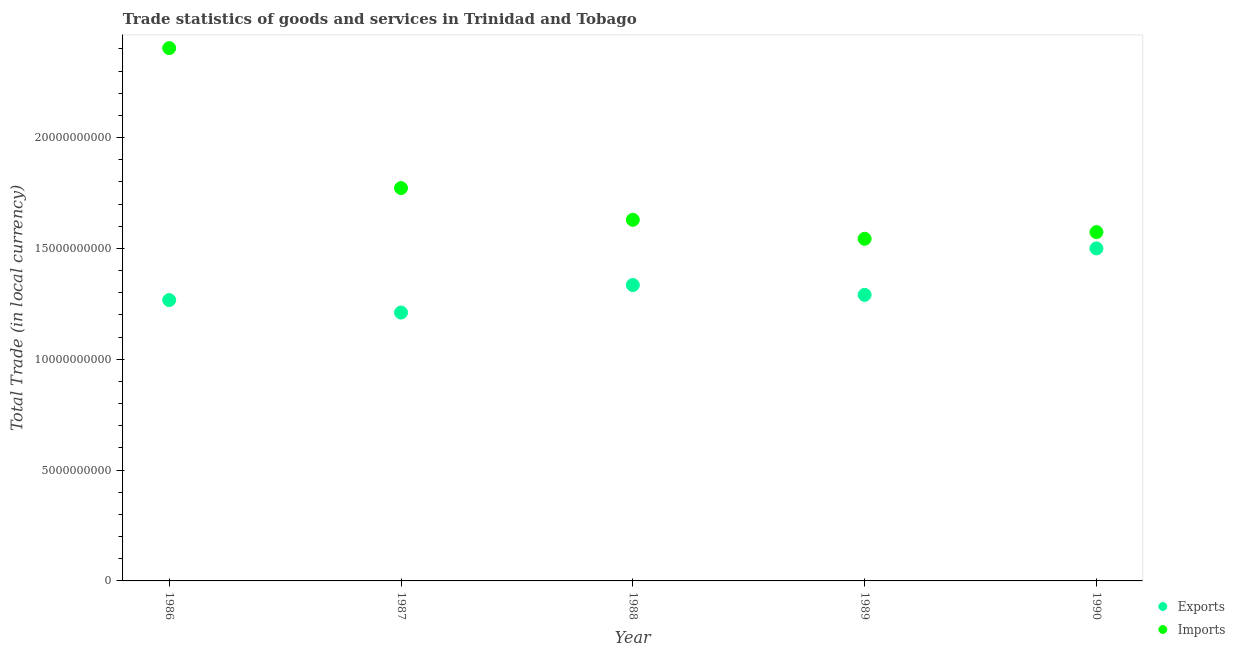Is the number of dotlines equal to the number of legend labels?
Your answer should be very brief. Yes. What is the export of goods and services in 1987?
Ensure brevity in your answer.  1.21e+1. Across all years, what is the maximum imports of goods and services?
Offer a very short reply. 2.40e+1. Across all years, what is the minimum imports of goods and services?
Provide a succinct answer. 1.54e+1. In which year was the imports of goods and services maximum?
Provide a short and direct response. 1986. What is the total export of goods and services in the graph?
Provide a short and direct response. 6.60e+1. What is the difference between the export of goods and services in 1987 and that in 1990?
Keep it short and to the point. -2.89e+09. What is the difference between the imports of goods and services in 1990 and the export of goods and services in 1986?
Provide a succinct answer. 3.07e+09. What is the average imports of goods and services per year?
Your response must be concise. 1.78e+1. In the year 1988, what is the difference between the imports of goods and services and export of goods and services?
Ensure brevity in your answer.  2.94e+09. In how many years, is the export of goods and services greater than 5000000000 LCU?
Provide a succinct answer. 5. What is the ratio of the export of goods and services in 1987 to that in 1989?
Ensure brevity in your answer.  0.94. Is the difference between the imports of goods and services in 1987 and 1990 greater than the difference between the export of goods and services in 1987 and 1990?
Make the answer very short. Yes. What is the difference between the highest and the second highest imports of goods and services?
Provide a succinct answer. 6.32e+09. What is the difference between the highest and the lowest export of goods and services?
Ensure brevity in your answer.  2.89e+09. In how many years, is the export of goods and services greater than the average export of goods and services taken over all years?
Your response must be concise. 2. Is the sum of the export of goods and services in 1987 and 1988 greater than the maximum imports of goods and services across all years?
Ensure brevity in your answer.  Yes. Does the export of goods and services monotonically increase over the years?
Your answer should be compact. No. Is the imports of goods and services strictly greater than the export of goods and services over the years?
Make the answer very short. Yes. How many dotlines are there?
Give a very brief answer. 2. Does the graph contain any zero values?
Offer a terse response. No. Does the graph contain grids?
Ensure brevity in your answer.  No. How are the legend labels stacked?
Provide a short and direct response. Vertical. What is the title of the graph?
Your response must be concise. Trade statistics of goods and services in Trinidad and Tobago. What is the label or title of the Y-axis?
Make the answer very short. Total Trade (in local currency). What is the Total Trade (in local currency) in Exports in 1986?
Give a very brief answer. 1.27e+1. What is the Total Trade (in local currency) of Imports in 1986?
Ensure brevity in your answer.  2.40e+1. What is the Total Trade (in local currency) in Exports in 1987?
Provide a short and direct response. 1.21e+1. What is the Total Trade (in local currency) in Imports in 1987?
Provide a short and direct response. 1.77e+1. What is the Total Trade (in local currency) in Exports in 1988?
Make the answer very short. 1.33e+1. What is the Total Trade (in local currency) in Imports in 1988?
Make the answer very short. 1.63e+1. What is the Total Trade (in local currency) in Exports in 1989?
Offer a very short reply. 1.29e+1. What is the Total Trade (in local currency) in Imports in 1989?
Give a very brief answer. 1.54e+1. What is the Total Trade (in local currency) in Exports in 1990?
Keep it short and to the point. 1.50e+1. What is the Total Trade (in local currency) of Imports in 1990?
Ensure brevity in your answer.  1.57e+1. Across all years, what is the maximum Total Trade (in local currency) of Exports?
Make the answer very short. 1.50e+1. Across all years, what is the maximum Total Trade (in local currency) in Imports?
Offer a terse response. 2.40e+1. Across all years, what is the minimum Total Trade (in local currency) of Exports?
Make the answer very short. 1.21e+1. Across all years, what is the minimum Total Trade (in local currency) in Imports?
Offer a very short reply. 1.54e+1. What is the total Total Trade (in local currency) of Exports in the graph?
Keep it short and to the point. 6.60e+1. What is the total Total Trade (in local currency) of Imports in the graph?
Ensure brevity in your answer.  8.92e+1. What is the difference between the Total Trade (in local currency) in Exports in 1986 and that in 1987?
Provide a succinct answer. 5.63e+08. What is the difference between the Total Trade (in local currency) of Imports in 1986 and that in 1987?
Give a very brief answer. 6.32e+09. What is the difference between the Total Trade (in local currency) in Exports in 1986 and that in 1988?
Your answer should be very brief. -6.79e+08. What is the difference between the Total Trade (in local currency) in Imports in 1986 and that in 1988?
Your answer should be compact. 7.75e+09. What is the difference between the Total Trade (in local currency) in Exports in 1986 and that in 1989?
Your response must be concise. -2.36e+08. What is the difference between the Total Trade (in local currency) in Imports in 1986 and that in 1989?
Offer a terse response. 8.60e+09. What is the difference between the Total Trade (in local currency) in Exports in 1986 and that in 1990?
Ensure brevity in your answer.  -2.33e+09. What is the difference between the Total Trade (in local currency) of Imports in 1986 and that in 1990?
Offer a terse response. 8.30e+09. What is the difference between the Total Trade (in local currency) of Exports in 1987 and that in 1988?
Offer a terse response. -1.24e+09. What is the difference between the Total Trade (in local currency) in Imports in 1987 and that in 1988?
Offer a very short reply. 1.43e+09. What is the difference between the Total Trade (in local currency) of Exports in 1987 and that in 1989?
Make the answer very short. -7.99e+08. What is the difference between the Total Trade (in local currency) in Imports in 1987 and that in 1989?
Provide a succinct answer. 2.29e+09. What is the difference between the Total Trade (in local currency) of Exports in 1987 and that in 1990?
Give a very brief answer. -2.89e+09. What is the difference between the Total Trade (in local currency) of Imports in 1987 and that in 1990?
Make the answer very short. 1.99e+09. What is the difference between the Total Trade (in local currency) in Exports in 1988 and that in 1989?
Give a very brief answer. 4.43e+08. What is the difference between the Total Trade (in local currency) in Imports in 1988 and that in 1989?
Keep it short and to the point. 8.56e+08. What is the difference between the Total Trade (in local currency) in Exports in 1988 and that in 1990?
Make the answer very short. -1.65e+09. What is the difference between the Total Trade (in local currency) in Imports in 1988 and that in 1990?
Your response must be concise. 5.55e+08. What is the difference between the Total Trade (in local currency) of Exports in 1989 and that in 1990?
Your answer should be very brief. -2.10e+09. What is the difference between the Total Trade (in local currency) in Imports in 1989 and that in 1990?
Your response must be concise. -3.01e+08. What is the difference between the Total Trade (in local currency) in Exports in 1986 and the Total Trade (in local currency) in Imports in 1987?
Ensure brevity in your answer.  -5.05e+09. What is the difference between the Total Trade (in local currency) in Exports in 1986 and the Total Trade (in local currency) in Imports in 1988?
Ensure brevity in your answer.  -3.62e+09. What is the difference between the Total Trade (in local currency) of Exports in 1986 and the Total Trade (in local currency) of Imports in 1989?
Offer a very short reply. -2.76e+09. What is the difference between the Total Trade (in local currency) of Exports in 1986 and the Total Trade (in local currency) of Imports in 1990?
Make the answer very short. -3.07e+09. What is the difference between the Total Trade (in local currency) of Exports in 1987 and the Total Trade (in local currency) of Imports in 1988?
Give a very brief answer. -4.18e+09. What is the difference between the Total Trade (in local currency) in Exports in 1987 and the Total Trade (in local currency) in Imports in 1989?
Your answer should be very brief. -3.33e+09. What is the difference between the Total Trade (in local currency) in Exports in 1987 and the Total Trade (in local currency) in Imports in 1990?
Provide a short and direct response. -3.63e+09. What is the difference between the Total Trade (in local currency) in Exports in 1988 and the Total Trade (in local currency) in Imports in 1989?
Offer a terse response. -2.09e+09. What is the difference between the Total Trade (in local currency) in Exports in 1988 and the Total Trade (in local currency) in Imports in 1990?
Offer a very short reply. -2.39e+09. What is the difference between the Total Trade (in local currency) in Exports in 1989 and the Total Trade (in local currency) in Imports in 1990?
Your response must be concise. -2.83e+09. What is the average Total Trade (in local currency) of Exports per year?
Your answer should be very brief. 1.32e+1. What is the average Total Trade (in local currency) of Imports per year?
Provide a short and direct response. 1.78e+1. In the year 1986, what is the difference between the Total Trade (in local currency) of Exports and Total Trade (in local currency) of Imports?
Offer a very short reply. -1.14e+1. In the year 1987, what is the difference between the Total Trade (in local currency) of Exports and Total Trade (in local currency) of Imports?
Your answer should be compact. -5.62e+09. In the year 1988, what is the difference between the Total Trade (in local currency) in Exports and Total Trade (in local currency) in Imports?
Give a very brief answer. -2.94e+09. In the year 1989, what is the difference between the Total Trade (in local currency) of Exports and Total Trade (in local currency) of Imports?
Offer a terse response. -2.53e+09. In the year 1990, what is the difference between the Total Trade (in local currency) in Exports and Total Trade (in local currency) in Imports?
Provide a succinct answer. -7.35e+08. What is the ratio of the Total Trade (in local currency) in Exports in 1986 to that in 1987?
Your answer should be very brief. 1.05. What is the ratio of the Total Trade (in local currency) of Imports in 1986 to that in 1987?
Give a very brief answer. 1.36. What is the ratio of the Total Trade (in local currency) of Exports in 1986 to that in 1988?
Provide a succinct answer. 0.95. What is the ratio of the Total Trade (in local currency) in Imports in 1986 to that in 1988?
Provide a succinct answer. 1.48. What is the ratio of the Total Trade (in local currency) in Exports in 1986 to that in 1989?
Provide a short and direct response. 0.98. What is the ratio of the Total Trade (in local currency) in Imports in 1986 to that in 1989?
Ensure brevity in your answer.  1.56. What is the ratio of the Total Trade (in local currency) of Exports in 1986 to that in 1990?
Ensure brevity in your answer.  0.84. What is the ratio of the Total Trade (in local currency) of Imports in 1986 to that in 1990?
Your answer should be compact. 1.53. What is the ratio of the Total Trade (in local currency) of Exports in 1987 to that in 1988?
Give a very brief answer. 0.91. What is the ratio of the Total Trade (in local currency) of Imports in 1987 to that in 1988?
Your response must be concise. 1.09. What is the ratio of the Total Trade (in local currency) in Exports in 1987 to that in 1989?
Keep it short and to the point. 0.94. What is the ratio of the Total Trade (in local currency) in Imports in 1987 to that in 1989?
Offer a terse response. 1.15. What is the ratio of the Total Trade (in local currency) of Exports in 1987 to that in 1990?
Offer a very short reply. 0.81. What is the ratio of the Total Trade (in local currency) in Imports in 1987 to that in 1990?
Your response must be concise. 1.13. What is the ratio of the Total Trade (in local currency) of Exports in 1988 to that in 1989?
Provide a succinct answer. 1.03. What is the ratio of the Total Trade (in local currency) of Imports in 1988 to that in 1989?
Provide a short and direct response. 1.06. What is the ratio of the Total Trade (in local currency) in Exports in 1988 to that in 1990?
Give a very brief answer. 0.89. What is the ratio of the Total Trade (in local currency) in Imports in 1988 to that in 1990?
Make the answer very short. 1.04. What is the ratio of the Total Trade (in local currency) in Exports in 1989 to that in 1990?
Provide a short and direct response. 0.86. What is the ratio of the Total Trade (in local currency) in Imports in 1989 to that in 1990?
Provide a short and direct response. 0.98. What is the difference between the highest and the second highest Total Trade (in local currency) in Exports?
Your response must be concise. 1.65e+09. What is the difference between the highest and the second highest Total Trade (in local currency) of Imports?
Provide a succinct answer. 6.32e+09. What is the difference between the highest and the lowest Total Trade (in local currency) of Exports?
Give a very brief answer. 2.89e+09. What is the difference between the highest and the lowest Total Trade (in local currency) in Imports?
Provide a short and direct response. 8.60e+09. 